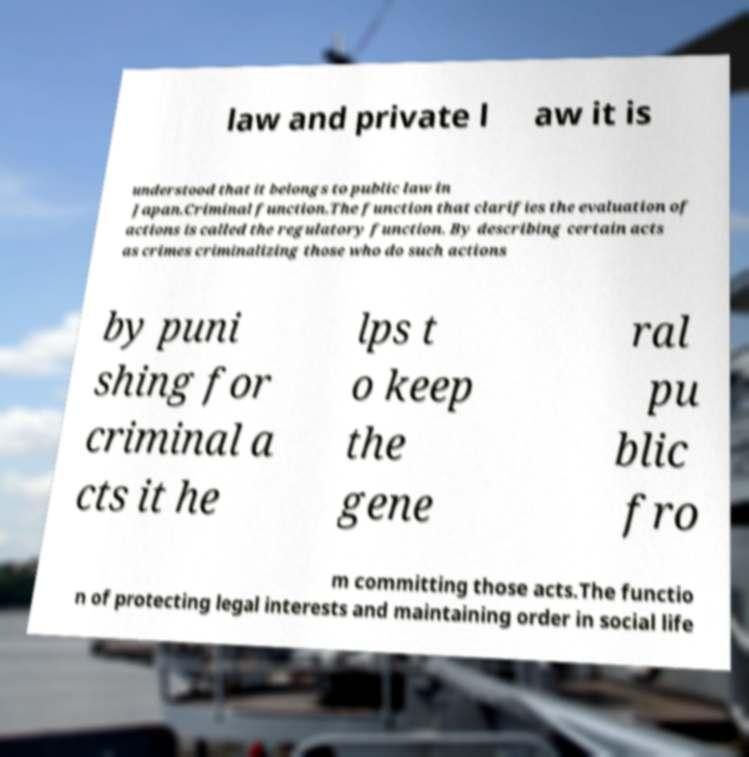Could you assist in decoding the text presented in this image and type it out clearly? law and private l aw it is understood that it belongs to public law in Japan.Criminal function.The function that clarifies the evaluation of actions is called the regulatory function. By describing certain acts as crimes criminalizing those who do such actions by puni shing for criminal a cts it he lps t o keep the gene ral pu blic fro m committing those acts.The functio n of protecting legal interests and maintaining order in social life 